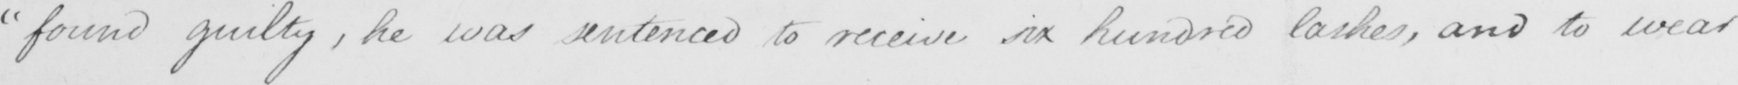Can you tell me what this handwritten text says? " found guilty , he was sentenced to receive six hundred lashes , and to wear 